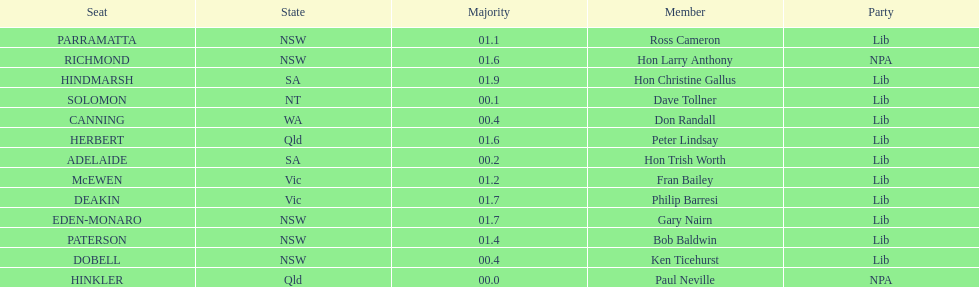What party had the most seats? Lib. 